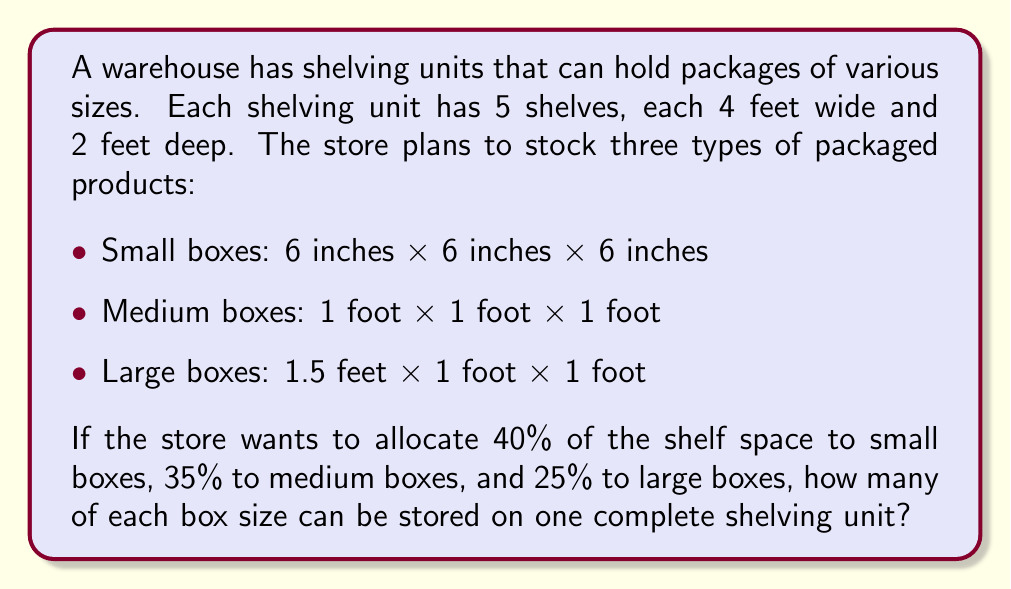Show me your answer to this math problem. Let's approach this problem step by step:

1) First, calculate the total shelf area:
   $$ \text{Total area} = 5 \text{ shelves} \times 4 \text{ ft} \times 2 \text{ ft} = 40 \text{ sq ft} $$

2) Now, determine the area allocated to each box size:
   - Small boxes: $40\% \text{ of } 40 \text{ sq ft} = 0.4 \times 40 = 16 \text{ sq ft}$
   - Medium boxes: $35\% \text{ of } 40 \text{ sq ft} = 0.35 \times 40 = 14 \text{ sq ft}$
   - Large boxes: $25\% \text{ of } 40 \text{ sq ft} = 0.25 \times 40 = 10 \text{ sq ft}$

3) Calculate the area each box occupies:
   - Small box: $0.5 \text{ ft} \times 0.5 \text{ ft} = 0.25 \text{ sq ft}$
   - Medium box: $1 \text{ ft} \times 1 \text{ ft} = 1 \text{ sq ft}$
   - Large box: $1.5 \text{ ft} \times 1 \text{ ft} = 1.5 \text{ sq ft}$

4) Determine the number of boxes that can fit in the allocated space:
   - Small boxes: $16 \text{ sq ft} \div 0.25 \text{ sq ft} = 64 \text{ boxes}$
   - Medium boxes: $14 \text{ sq ft} \div 1 \text{ sq ft} = 14 \text{ boxes}$
   - Large boxes: $10 \text{ sq ft} \div 1.5 \text{ sq ft} = 6.67 \text{ boxes}$

5) Round down to the nearest whole number for large boxes:
   - Large boxes: 6 boxes

Therefore, one complete shelving unit can store 64 small boxes, 14 medium boxes, and 6 large boxes.
Answer: 64 small boxes, 14 medium boxes, and 6 large boxes 